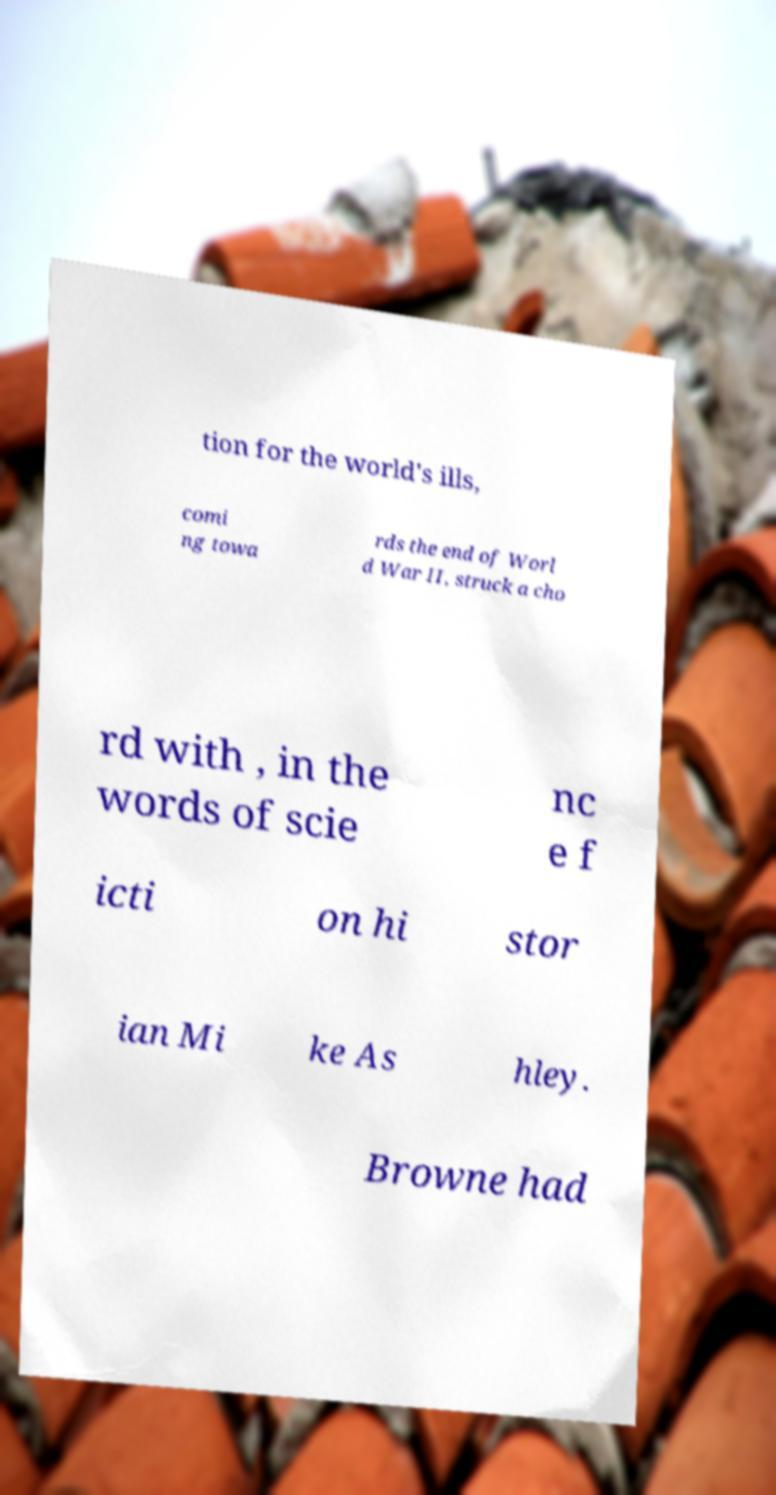Please read and relay the text visible in this image. What does it say? tion for the world's ills, comi ng towa rds the end of Worl d War II, struck a cho rd with , in the words of scie nc e f icti on hi stor ian Mi ke As hley. Browne had 